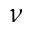Convert formula to latex. <formula><loc_0><loc_0><loc_500><loc_500>\nu</formula> 